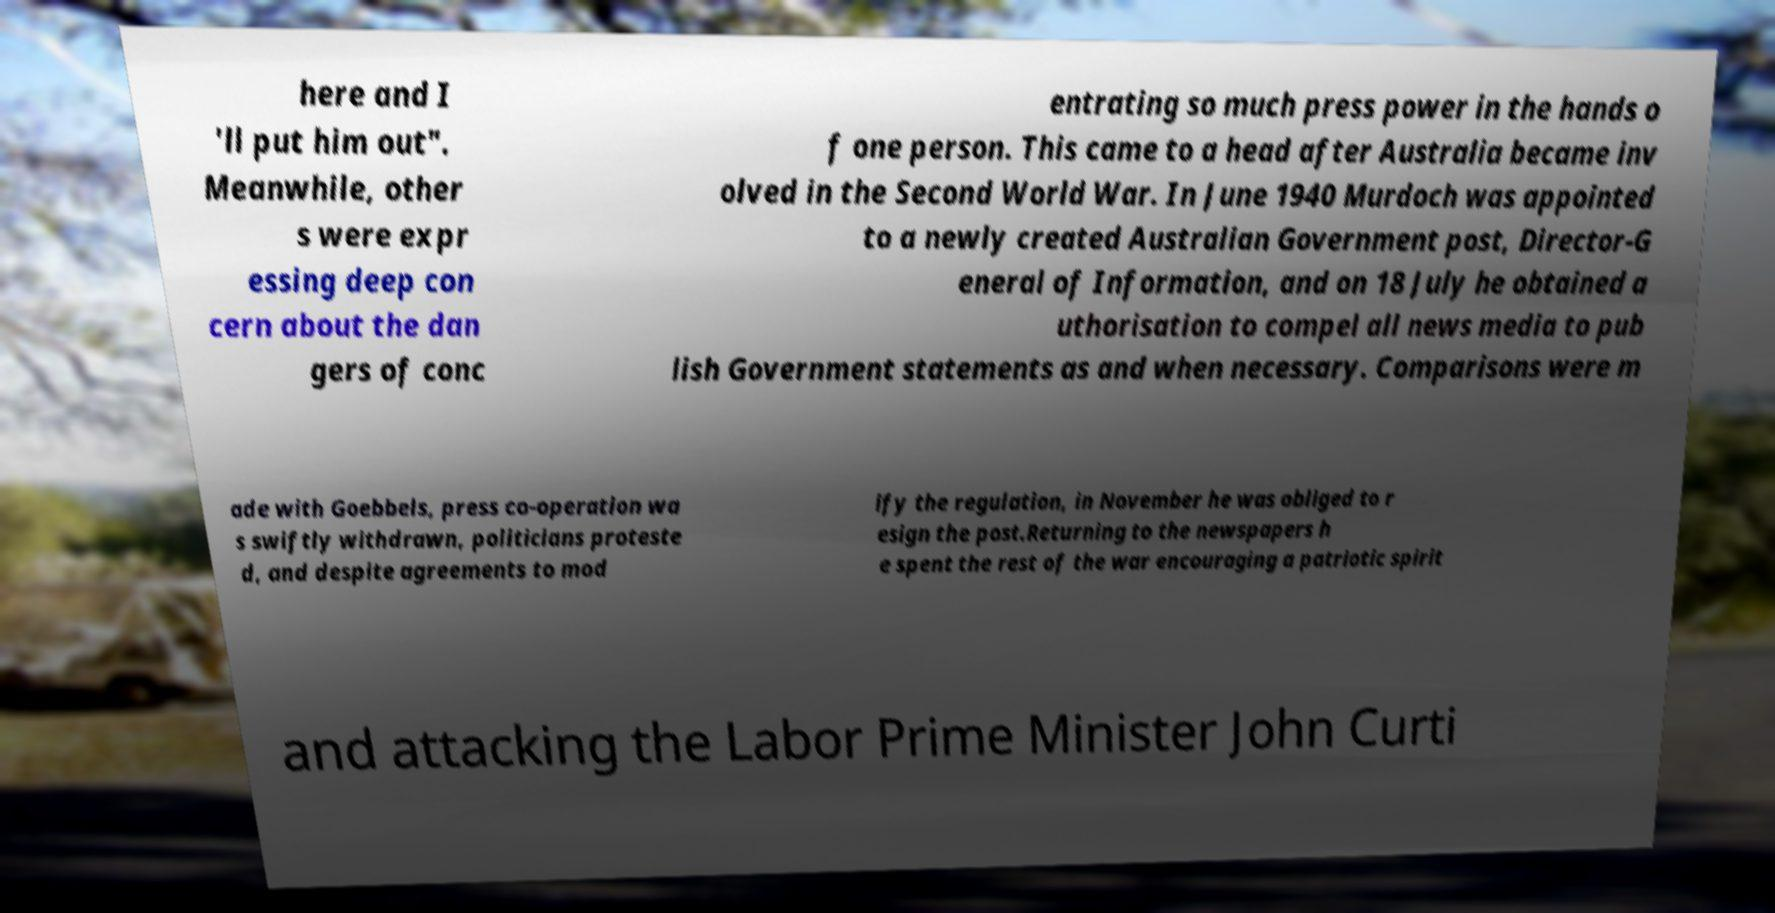There's text embedded in this image that I need extracted. Can you transcribe it verbatim? here and I 'll put him out". Meanwhile, other s were expr essing deep con cern about the dan gers of conc entrating so much press power in the hands o f one person. This came to a head after Australia became inv olved in the Second World War. In June 1940 Murdoch was appointed to a newly created Australian Government post, Director-G eneral of Information, and on 18 July he obtained a uthorisation to compel all news media to pub lish Government statements as and when necessary. Comparisons were m ade with Goebbels, press co-operation wa s swiftly withdrawn, politicians proteste d, and despite agreements to mod ify the regulation, in November he was obliged to r esign the post.Returning to the newspapers h e spent the rest of the war encouraging a patriotic spirit and attacking the Labor Prime Minister John Curti 